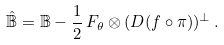Convert formula to latex. <formula><loc_0><loc_0><loc_500><loc_500>\hat { \mathbb { B } } = { \mathbb { B } } - \frac { 1 } { 2 } \, F _ { \theta } \otimes ( D ( f \circ \pi ) ) ^ { \bot } \, .</formula> 